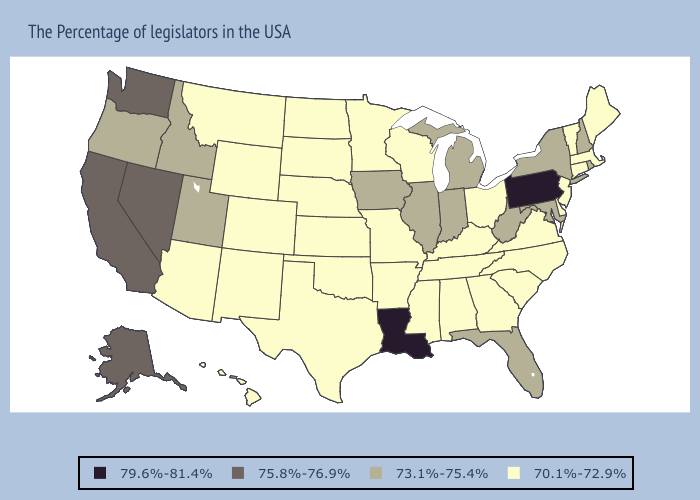Name the states that have a value in the range 75.8%-76.9%?
Keep it brief. Nevada, California, Washington, Alaska. Does South Carolina have a lower value than Wisconsin?
Quick response, please. No. Which states hav the highest value in the South?
Concise answer only. Louisiana. Among the states that border Louisiana , which have the lowest value?
Give a very brief answer. Mississippi, Arkansas, Texas. Name the states that have a value in the range 70.1%-72.9%?
Concise answer only. Maine, Massachusetts, Vermont, Connecticut, New Jersey, Delaware, Virginia, North Carolina, South Carolina, Ohio, Georgia, Kentucky, Alabama, Tennessee, Wisconsin, Mississippi, Missouri, Arkansas, Minnesota, Kansas, Nebraska, Oklahoma, Texas, South Dakota, North Dakota, Wyoming, Colorado, New Mexico, Montana, Arizona, Hawaii. Name the states that have a value in the range 75.8%-76.9%?
Answer briefly. Nevada, California, Washington, Alaska. Does Kentucky have the highest value in the USA?
Answer briefly. No. Does the first symbol in the legend represent the smallest category?
Be succinct. No. Name the states that have a value in the range 79.6%-81.4%?
Short answer required. Pennsylvania, Louisiana. What is the lowest value in states that border Arizona?
Answer briefly. 70.1%-72.9%. Does Minnesota have the lowest value in the MidWest?
Short answer required. Yes. Does Alabama have a lower value than California?
Be succinct. Yes. Name the states that have a value in the range 75.8%-76.9%?
Keep it brief. Nevada, California, Washington, Alaska. Which states have the lowest value in the USA?
Give a very brief answer. Maine, Massachusetts, Vermont, Connecticut, New Jersey, Delaware, Virginia, North Carolina, South Carolina, Ohio, Georgia, Kentucky, Alabama, Tennessee, Wisconsin, Mississippi, Missouri, Arkansas, Minnesota, Kansas, Nebraska, Oklahoma, Texas, South Dakota, North Dakota, Wyoming, Colorado, New Mexico, Montana, Arizona, Hawaii. Which states have the highest value in the USA?
Quick response, please. Pennsylvania, Louisiana. 